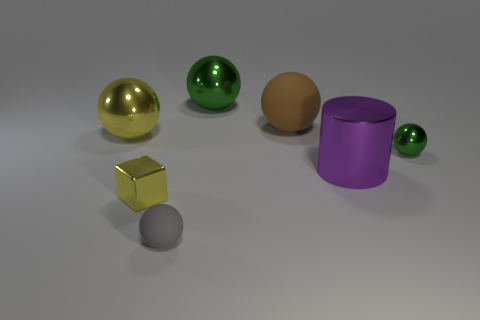How many big yellow metal things are in front of the tiny yellow metallic thing?
Your response must be concise. 0. Are there fewer tiny metal balls behind the brown ball than objects?
Your answer should be very brief. Yes. The small metal ball is what color?
Give a very brief answer. Green. Do the small sphere behind the tiny cube and the tiny shiny block have the same color?
Give a very brief answer. No. The other small object that is the same shape as the small green thing is what color?
Keep it short and to the point. Gray. How many tiny objects are either purple shiny things or yellow balls?
Your answer should be very brief. 0. There is a yellow shiny object that is to the right of the large yellow metallic sphere; what is its size?
Offer a very short reply. Small. Are there any other tiny shiny cubes that have the same color as the tiny cube?
Your answer should be compact. No. Do the big rubber sphere and the metallic cylinder have the same color?
Make the answer very short. No. What is the shape of the big metallic thing that is the same color as the small cube?
Your answer should be compact. Sphere. 